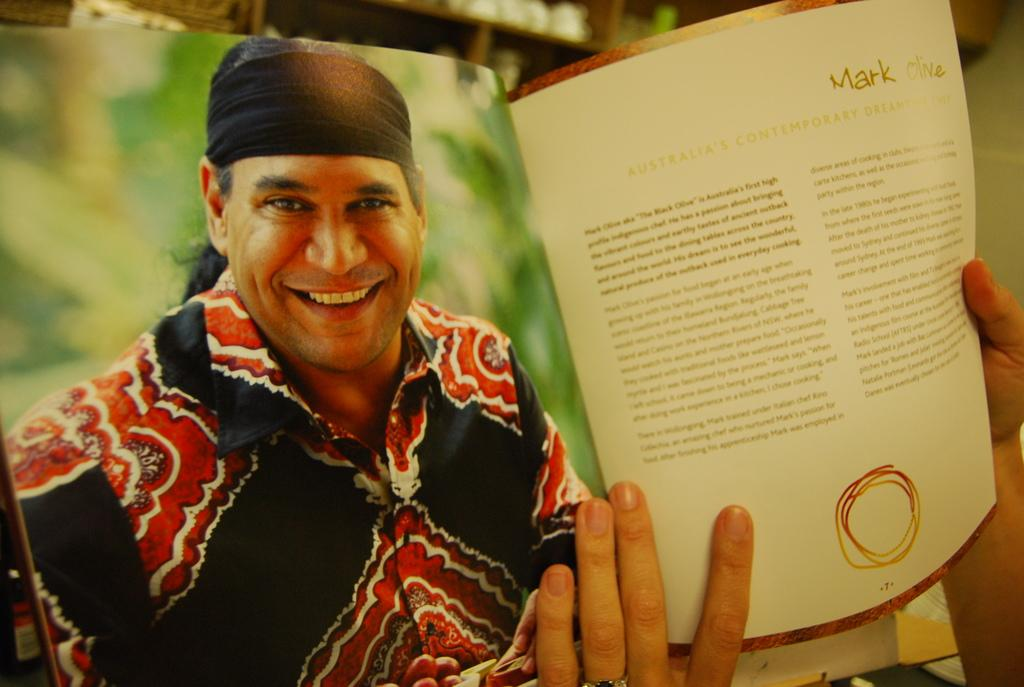What is the person in the image holding? The person is holding a book in the image. Can you describe the book? The book has writing on it and an image of a smiling man. How would you describe the background of the image? The background of the image is blurred. What type of dog can be seen eating popcorn in the image? There is no dog or popcorn present in the image. Can you describe the blade used by the person in the image? There is no blade visible in the image; the person is holding a book. 